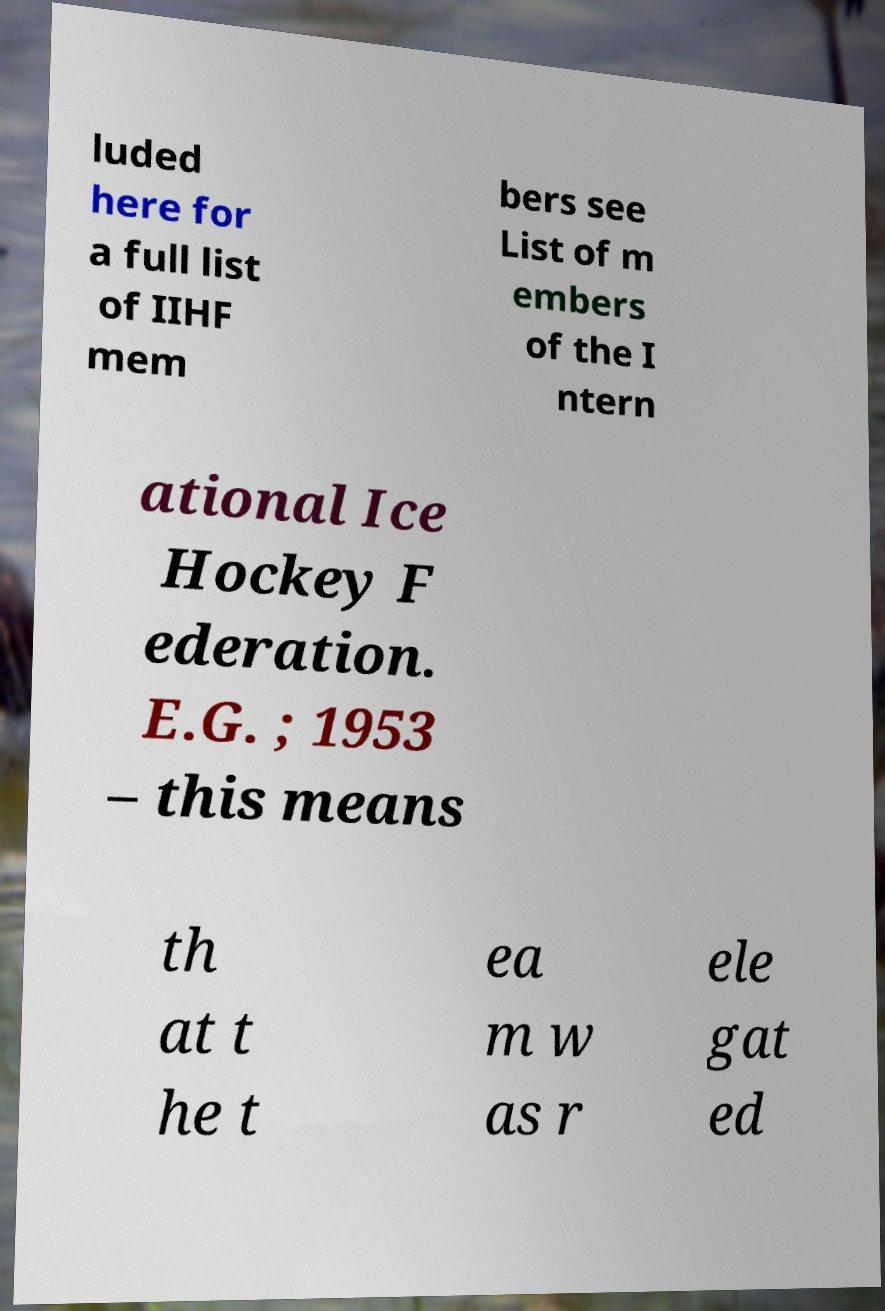Could you extract and type out the text from this image? luded here for a full list of IIHF mem bers see List of m embers of the I ntern ational Ice Hockey F ederation. E.G. ; 1953 – this means th at t he t ea m w as r ele gat ed 